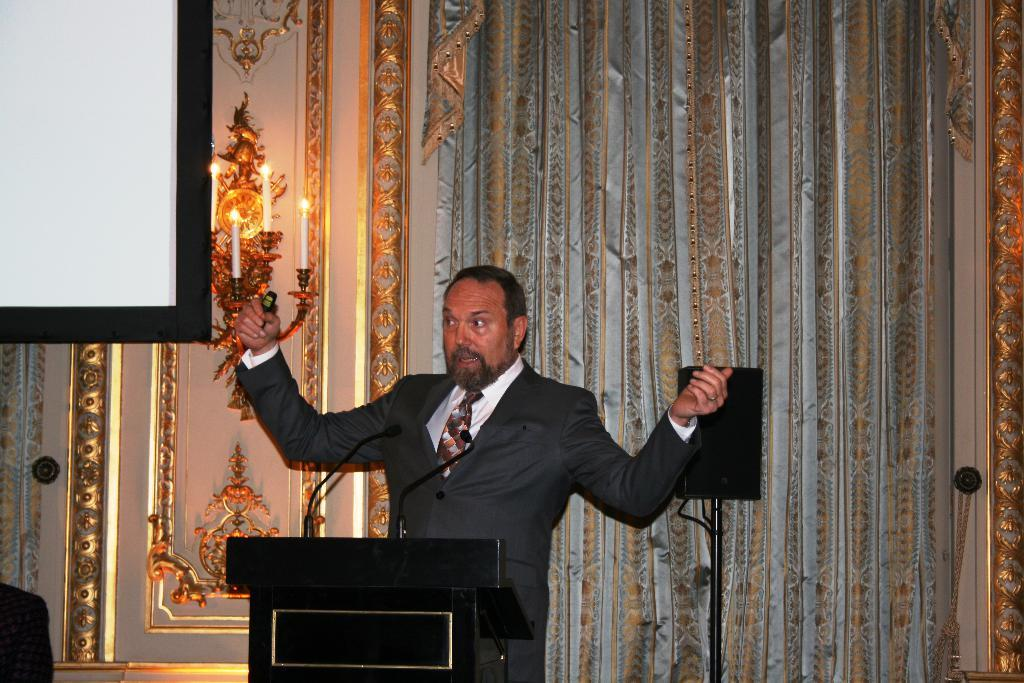What is the main subject in the image? There is a person standing in the image. What object can be seen near the person? There is a podium in the image. What type of decorative element is present in the image? There are curtains in the image. What object might be used for holding a candle? There is a candle holder in the image. What device is present for amplifying sound? There is a microphone in the image. What is the purpose of the screen in the image? There is a screen in the image, which might be used for displaying information or visuals. What type of eye can be seen on the person in the image? There is no eye visible on the person in the image; only their body is shown. 